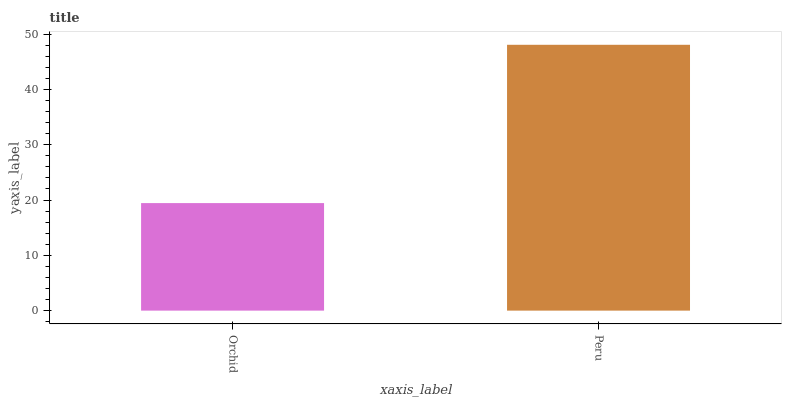Is Orchid the minimum?
Answer yes or no. Yes. Is Peru the maximum?
Answer yes or no. Yes. Is Peru the minimum?
Answer yes or no. No. Is Peru greater than Orchid?
Answer yes or no. Yes. Is Orchid less than Peru?
Answer yes or no. Yes. Is Orchid greater than Peru?
Answer yes or no. No. Is Peru less than Orchid?
Answer yes or no. No. Is Peru the high median?
Answer yes or no. Yes. Is Orchid the low median?
Answer yes or no. Yes. Is Orchid the high median?
Answer yes or no. No. Is Peru the low median?
Answer yes or no. No. 